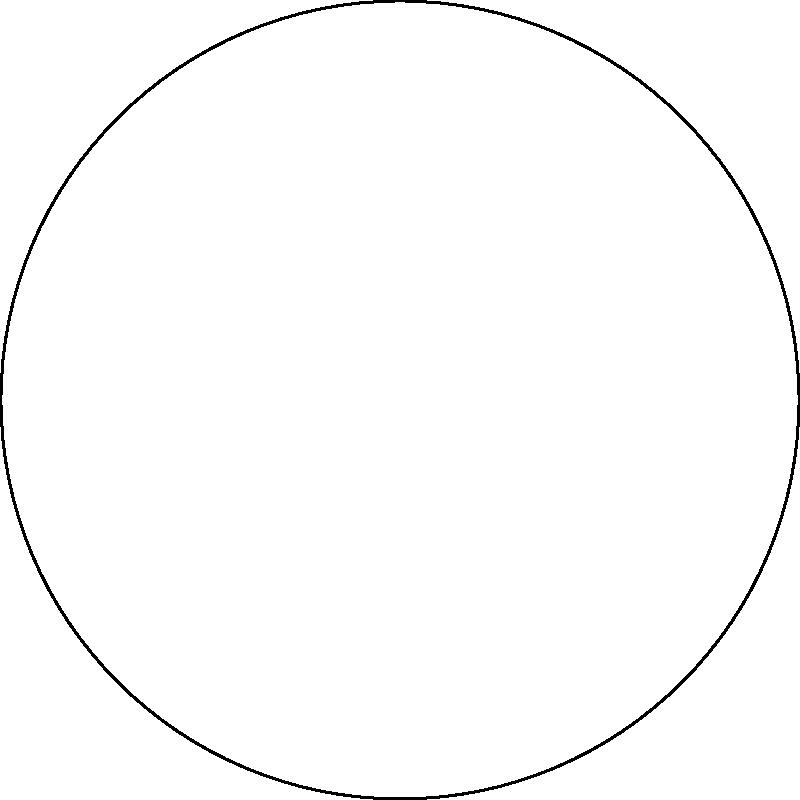At an Angelina Mango concert, a circular stage is designed with a sector cut out for the audience to get closer. The stage has a radius of 10 meters, and the sector removed spans an angle of 60°. What is the area of the remaining stage in square meters? Round your answer to two decimal places. Let's solve this step-by-step:

1) First, we need to calculate the area of the full circle:
   $$A_{circle} = \pi r^2 = \pi \cdot 10^2 = 100\pi \text{ m}^2$$

2) Next, we calculate the area of the sector that was removed:
   The sector angle is 60°, which is $\frac{60}{360} = \frac{1}{6}$ of the full circle.
   $$A_{sector} = \frac{1}{6} \cdot 100\pi = \frac{50\pi}{3} \text{ m}^2$$

3) The area of the remaining stage is the difference between these two:
   $$A_{stage} = A_{circle} - A_{sector} = 100\pi - \frac{50\pi}{3} = \frac{250\pi}{3} \text{ m}^2$$

4) Now we need to calculate this and round to two decimal places:
   $$\frac{250\pi}{3} \approx 261.80 \text{ m}^2$$

Therefore, the area of the remaining stage is approximately 261.80 square meters.
Answer: 261.80 m² 